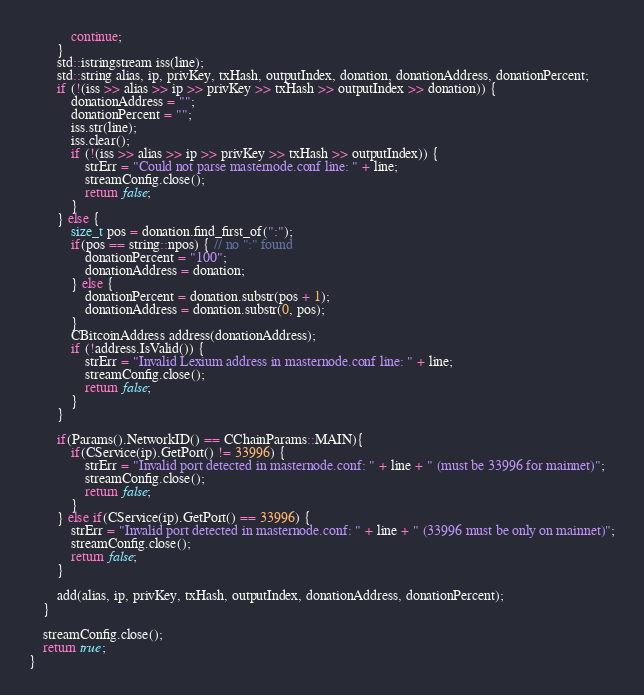<code> <loc_0><loc_0><loc_500><loc_500><_C++_>            continue;
        }
        std::istringstream iss(line);
        std::string alias, ip, privKey, txHash, outputIndex, donation, donationAddress, donationPercent;
        if (!(iss >> alias >> ip >> privKey >> txHash >> outputIndex >> donation)) {
            donationAddress = "";
            donationPercent = "";
            iss.str(line);
            iss.clear();
            if (!(iss >> alias >> ip >> privKey >> txHash >> outputIndex)) {
                strErr = "Could not parse masternode.conf line: " + line;
                streamConfig.close();
                return false;
            }
        } else {
            size_t pos = donation.find_first_of(":");
            if(pos == string::npos) { // no ":" found
                donationPercent = "100";
                donationAddress = donation;
            } else {
                donationPercent = donation.substr(pos + 1);
                donationAddress = donation.substr(0, pos);
            }
            CBitcoinAddress address(donationAddress);
            if (!address.IsValid()) {
                strErr = "Invalid Lexium address in masternode.conf line: " + line;
                streamConfig.close();
                return false;
            }
        }

        if(Params().NetworkID() == CChainParams::MAIN){
            if(CService(ip).GetPort() != 33996) {
                strErr = "Invalid port detected in masternode.conf: " + line + " (must be 33996 for mainnet)";
                streamConfig.close();
                return false;
            }
        } else if(CService(ip).GetPort() == 33996) {
            strErr = "Invalid port detected in masternode.conf: " + line + " (33996 must be only on mainnet)";
            streamConfig.close();
            return false;
        }

        add(alias, ip, privKey, txHash, outputIndex, donationAddress, donationPercent);
    }

    streamConfig.close();
    return true;
}
</code> 